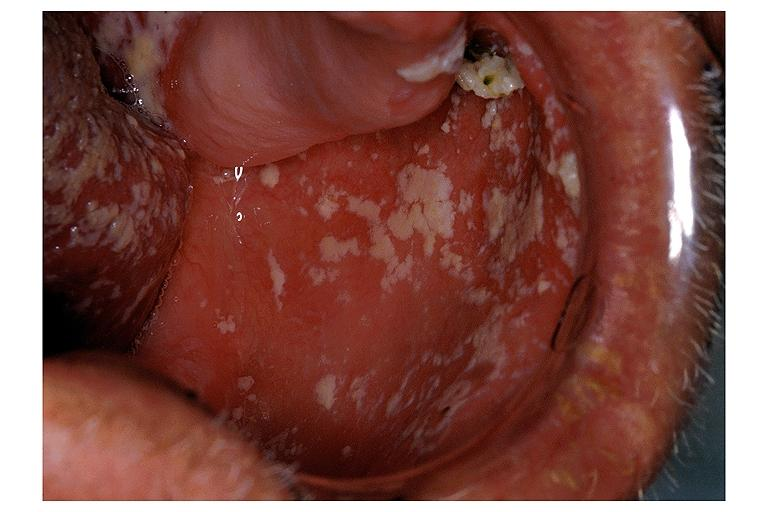does this image show candidiasis-pseudomembraneous?
Answer the question using a single word or phrase. Yes 